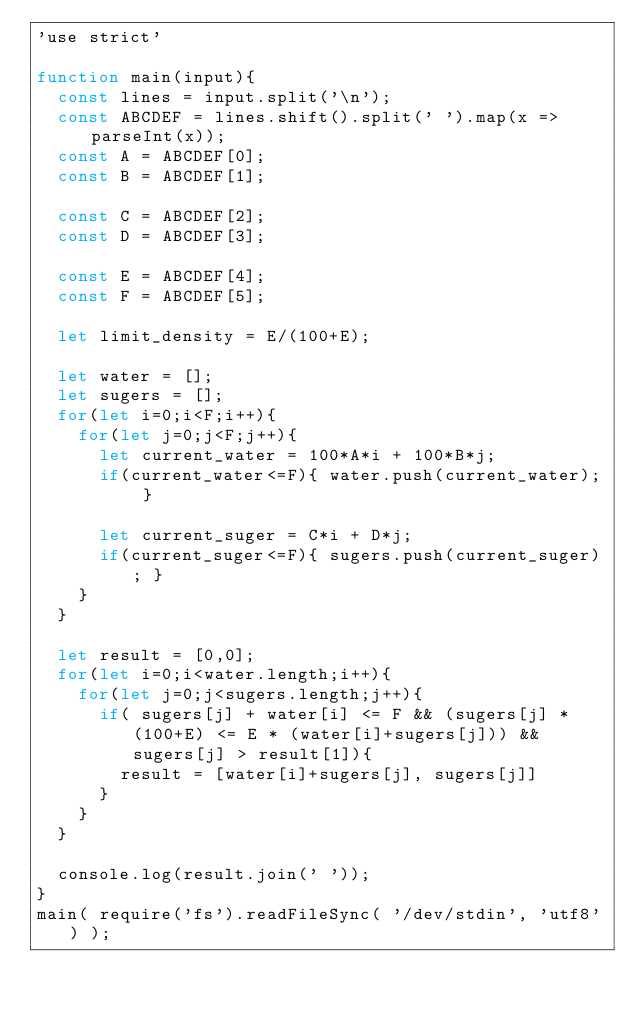Convert code to text. <code><loc_0><loc_0><loc_500><loc_500><_JavaScript_>'use strict'

function main(input){
  const lines = input.split('\n');
  const ABCDEF = lines.shift().split(' ').map(x => parseInt(x));
  const A = ABCDEF[0];
  const B = ABCDEF[1];

  const C = ABCDEF[2];
  const D = ABCDEF[3];

  const E = ABCDEF[4];
  const F = ABCDEF[5];

  let limit_density = E/(100+E);

  let water = [];
  let sugers = [];
  for(let i=0;i<F;i++){
    for(let j=0;j<F;j++){
      let current_water = 100*A*i + 100*B*j;
      if(current_water<=F){ water.push(current_water); }

      let current_suger = C*i + D*j;
      if(current_suger<=F){ sugers.push(current_suger); }
    }
  }

  let result = [0,0];
  for(let i=0;i<water.length;i++){
    for(let j=0;j<sugers.length;j++){
      if( sugers[j] + water[i] <= F && (sugers[j] * (100+E) <= E * (water[i]+sugers[j])) && sugers[j] > result[1]){
        result = [water[i]+sugers[j], sugers[j]]
      }
    }
  }

  console.log(result.join(' '));
}
main( require('fs').readFileSync( '/dev/stdin', 'utf8') );
</code> 